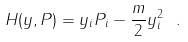<formula> <loc_0><loc_0><loc_500><loc_500>H ( { y } , { P } ) = y _ { i } P _ { i } - \frac { m } { 2 } y _ { i } ^ { 2 } \ .</formula> 